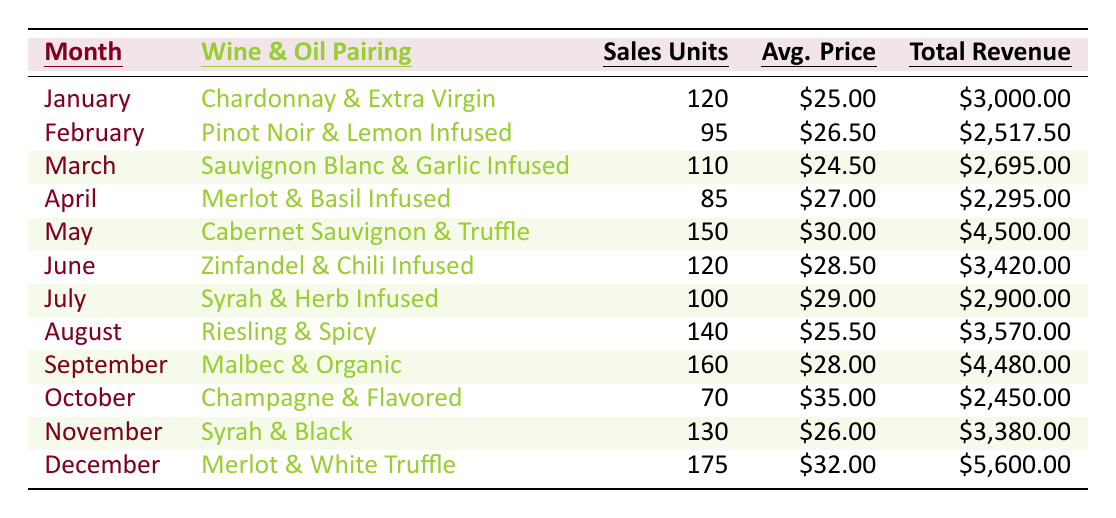What was the total revenue for May? The table shows that for May, the total revenue is listed as $4,500.00.
Answer: $4,500.00 How many sales units were recorded in February? From the table, we see that February has recorded 95 sales units.
Answer: 95 Which olive oil pairing had the highest average price per unit? By comparing the average prices per unit, the highest is in October with $35.00 for Flavored Olive Oil.
Answer: $35.00 What is the total revenue for the months of September and December combined? September's total revenue is $4,480.00 and December's is $5,600.00. Adding them gives $4,480.00 + $5,600.00 = $10,080.00.
Answer: $10,080.00 Did the sales units for Syrah in November exceed 100? The table indicates that Syrah in November had 130 sales units, which does exceed 100.
Answer: Yes What was the average sales units sold across all months in 2023? To find the average, calculate the total sales units: 120 + 95 + 110 + 85 + 150 + 120 + 100 + 140 + 160 + 70 + 130 + 175 = 1,460. Then divide by the number of months (12), giving 1,460 / 12 = 121.67.
Answer: 121.67 Which month had the lowest total revenue, and what was that revenue? By reviewing the total revenue column, April had the lowest total revenue of $2,295.00.
Answer: April, $2,295.00 If you combine the sales units from January, March, and April, how many units were sold in total? January has 120, March has 110, and April has 85. Adding these together gives 120 + 110 + 85 = 315 total sales units.
Answer: 315 What percentage of total revenue in June was derived from the average price per unit? In June, total revenue is $3,420.00, and the average price per unit is $28.50. First, calculate the total sales value from the average price: 120 units * $28.50 = $3,420.00, which is 100% of the total revenue.
Answer: 100% Which wine had the highest sales units for 2023, and what was the unit count? The highest sales were recorded in December for Merlot at 175 sales units.
Answer: Merlot, 175 